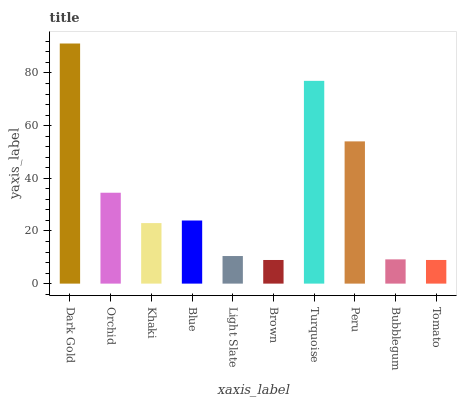Is Brown the minimum?
Answer yes or no. Yes. Is Dark Gold the maximum?
Answer yes or no. Yes. Is Orchid the minimum?
Answer yes or no. No. Is Orchid the maximum?
Answer yes or no. No. Is Dark Gold greater than Orchid?
Answer yes or no. Yes. Is Orchid less than Dark Gold?
Answer yes or no. Yes. Is Orchid greater than Dark Gold?
Answer yes or no. No. Is Dark Gold less than Orchid?
Answer yes or no. No. Is Blue the high median?
Answer yes or no. Yes. Is Khaki the low median?
Answer yes or no. Yes. Is Light Slate the high median?
Answer yes or no. No. Is Orchid the low median?
Answer yes or no. No. 